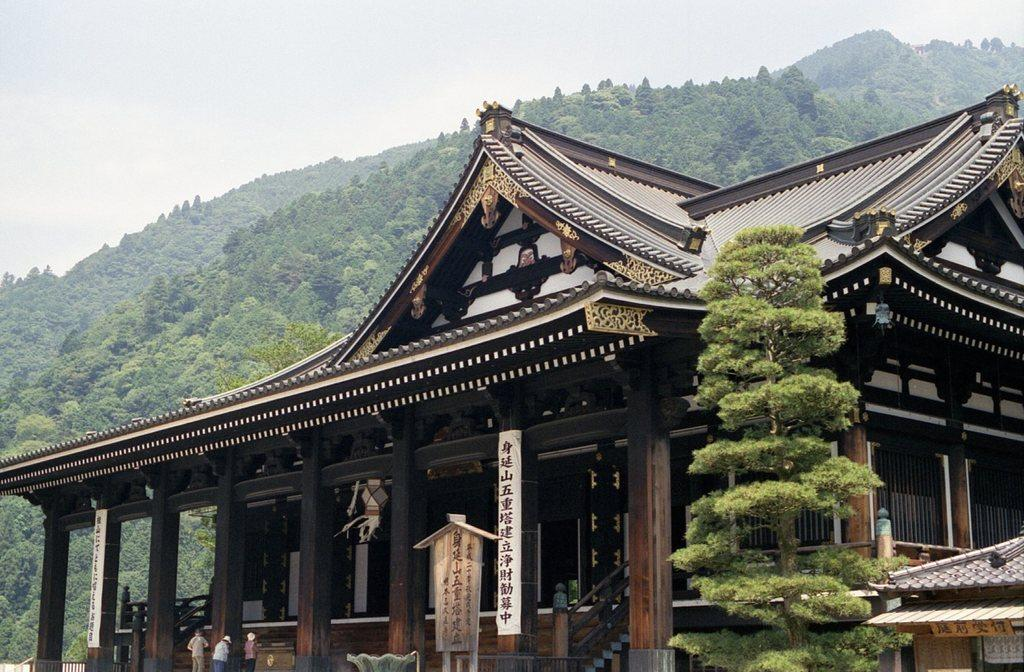What type of structure is present in the image? There is a building in the image. What natural elements can be seen in the image? There are trees and hills visible in the image. What objects are present in the image? There are boards in the image. Are there any living beings in the image? Yes, there are people in the image. What is visible in the background of the image? The sky is visible in the image. What type of wool is being used by the worm in the image? There is no worm or wool present in the image. What part of the building is being used by the people in the image? The provided facts do not specify which part of the building the people are in, so we cannot answer this question definitively. 